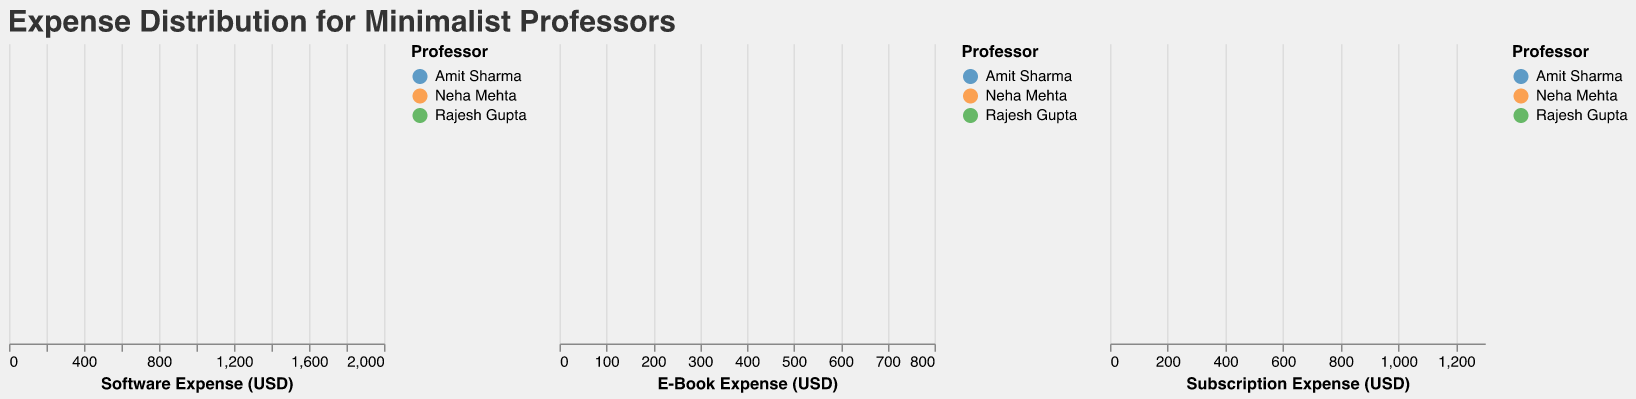What is the title of the figure? The title of the figure is typically displayed at the top to provide an overview or main idea of what the figure represents. In this case, it's mentioned in the code snippet.
Answer: Expense Distribution for Minimalist Professors How many different professors' expenses are shown in the figure? The color encoding in the figure is used to distinguish between different professors. The legend shows the different professors.
Answer: Three Which professor has the highest density in E-Book expenses around $15? To answer this, look at the E-Book Expense subplot and identify the color corresponding to the highest peak around the $15 mark.
Answer: Neha Mehta What is the general range of Software Expenses for Amit Sharma? By examining the density plot for Software Expenses, we look at the spread of the density area corresponding to Amit Sharma's color.
Answer: $45 to $51 Which type of expense shows the most variability among the professors? By comparing the widths of the density plots for Software, E-Book, and Subscription Expenses, we can see which type covers the widest range of values.
Answer: Software Expense Does Rajesh Gupta's E-Book expense show a peak density higher than Amit Sharma's in any range? Look at the E-Book Expense subplot and compare the density peaks corresponding to Rajesh Gupta and Amit Sharma.
Answer: No In which expense category does Neha Mehta consistently have higher expenses compared to the others? By comparing all three subplots (Software, E-Book, and Subscription), observe the density peaks and figures for Neha Mehta relative to the others.
Answer: Software Expense What's the range of Subscription Expenses for Rajesh Gupta? By looking at the Subscription Expense density plot, identify the spread of the density area corresponding to Rajesh Gupta's color.
Answer: $35 to $38 Which professor has the most stable expenses over the months for Software? By assessing the density plot for Software Expenses and considering the consistency of peaks and spread for each professor.
Answer: Amit Sharma Do any professors have overlapping expenses in Software and Subscription categories? By examining both the Software Expense and Subscription Expense subplots, determine if any professor's expenses overlap in these categories.
Answer: Yes 